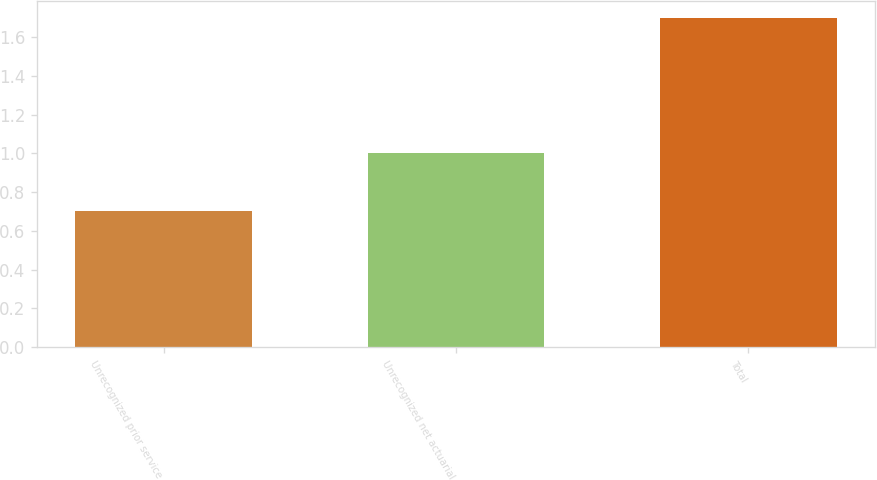Convert chart. <chart><loc_0><loc_0><loc_500><loc_500><bar_chart><fcel>Unrecognized prior service<fcel>Unrecognized net actuarial<fcel>Total<nl><fcel>0.7<fcel>1<fcel>1.7<nl></chart> 